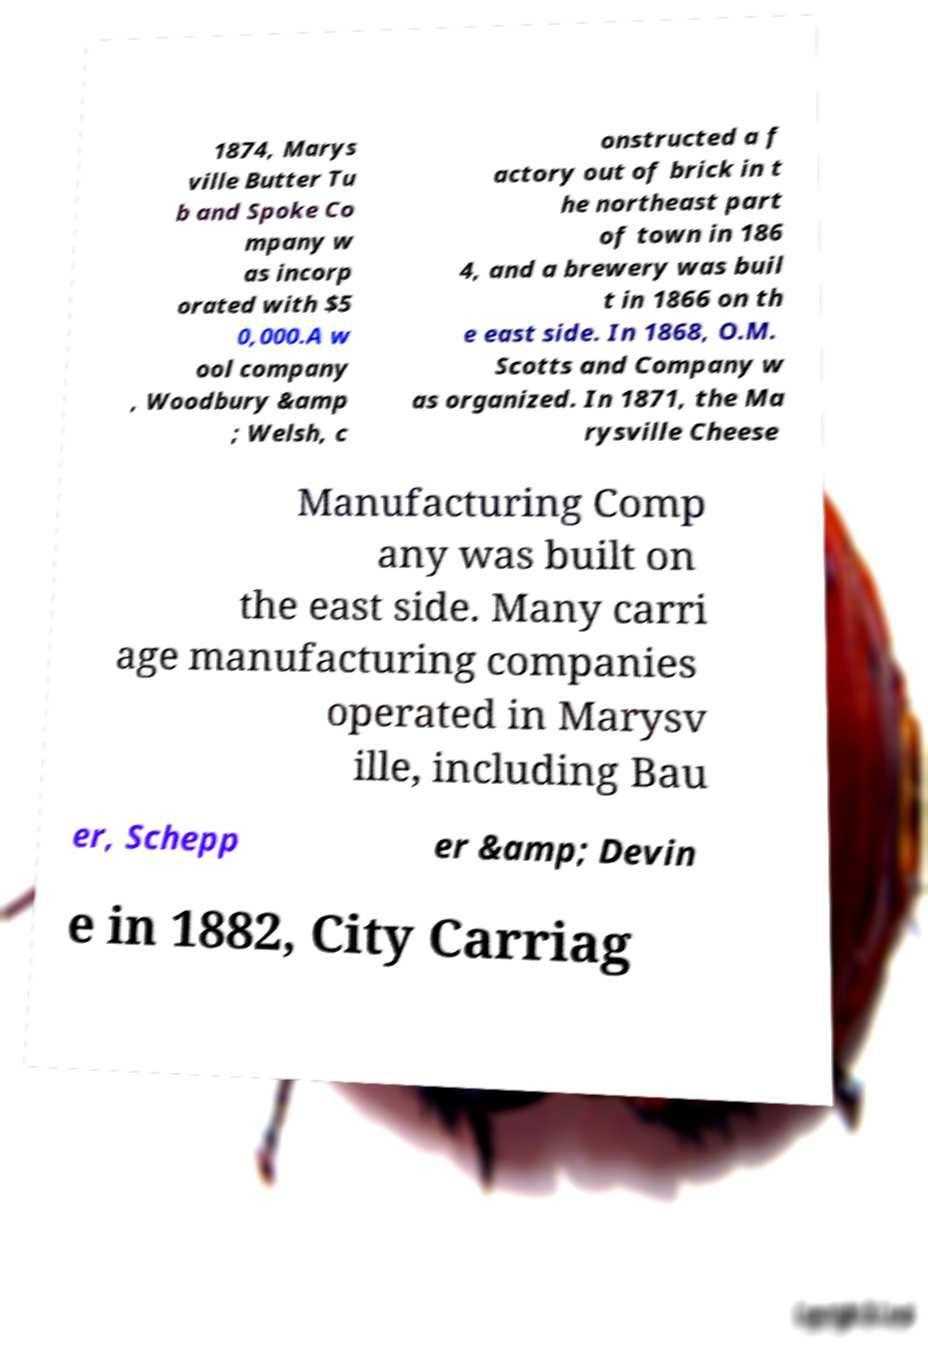Can you read and provide the text displayed in the image?This photo seems to have some interesting text. Can you extract and type it out for me? 1874, Marys ville Butter Tu b and Spoke Co mpany w as incorp orated with $5 0,000.A w ool company , Woodbury &amp ; Welsh, c onstructed a f actory out of brick in t he northeast part of town in 186 4, and a brewery was buil t in 1866 on th e east side. In 1868, O.M. Scotts and Company w as organized. In 1871, the Ma rysville Cheese Manufacturing Comp any was built on the east side. Many carri age manufacturing companies operated in Marysv ille, including Bau er, Schepp er &amp; Devin e in 1882, City Carriag 